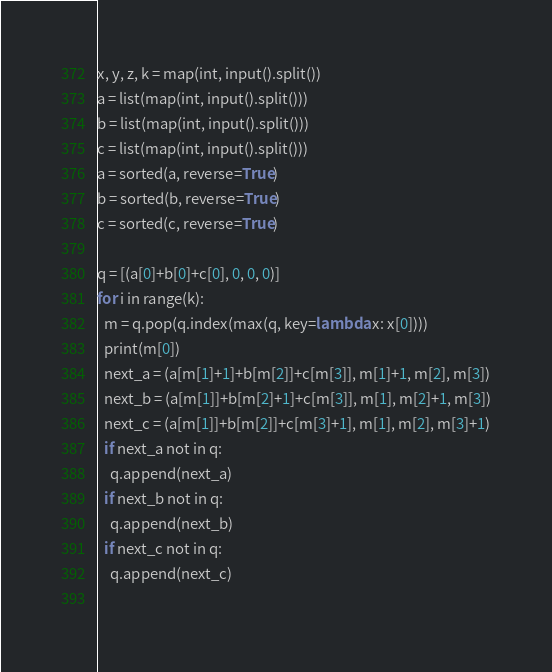<code> <loc_0><loc_0><loc_500><loc_500><_Python_>x, y, z, k = map(int, input().split())
a = list(map(int, input().split()))
b = list(map(int, input().split()))
c = list(map(int, input().split()))
a = sorted(a, reverse=True)
b = sorted(b, reverse=True)
c = sorted(c, reverse=True)

q = [(a[0]+b[0]+c[0], 0, 0, 0)]
for i in range(k):
  m = q.pop(q.index(max(q, key=lambda x: x[0])))
  print(m[0])
  next_a = (a[m[1]+1]+b[m[2]]+c[m[3]], m[1]+1, m[2], m[3])
  next_b = (a[m[1]]+b[m[2]+1]+c[m[3]], m[1], m[2]+1, m[3])
  next_c = (a[m[1]]+b[m[2]]+c[m[3]+1], m[1], m[2], m[3]+1)
  if next_a not in q:
    q.append(next_a)
  if next_b not in q:
    q.append(next_b)
  if next_c not in q:
    q.append(next_c)
      </code> 